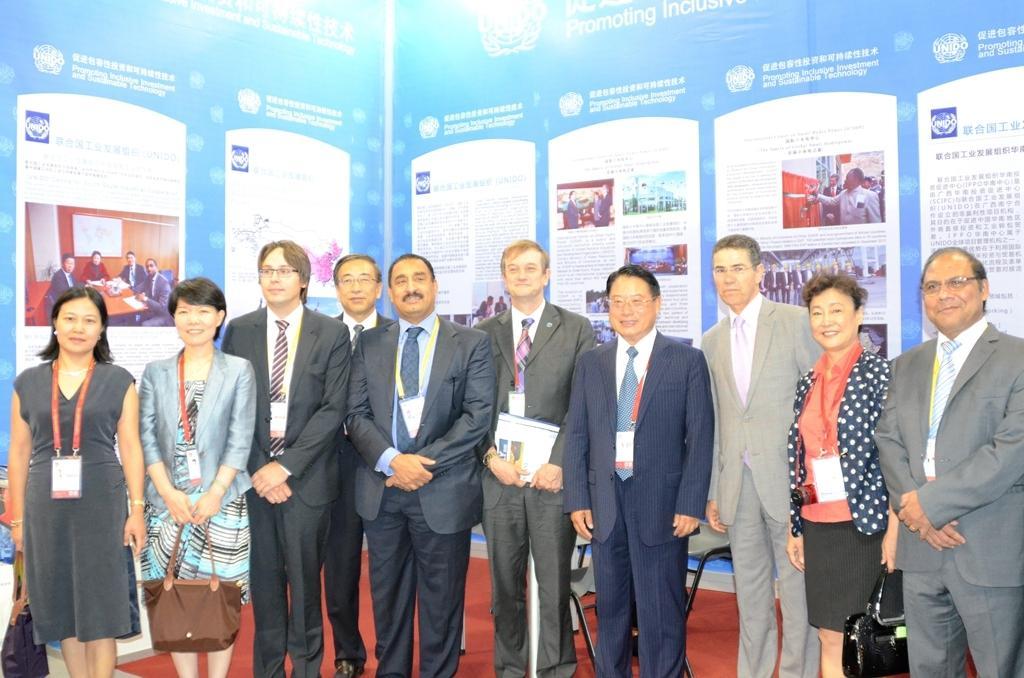Describe this image in one or two sentences. In this image I can see few people standing and wearing different color dress. Two people are holding bags. Back I can see a banner and something is written on it. 